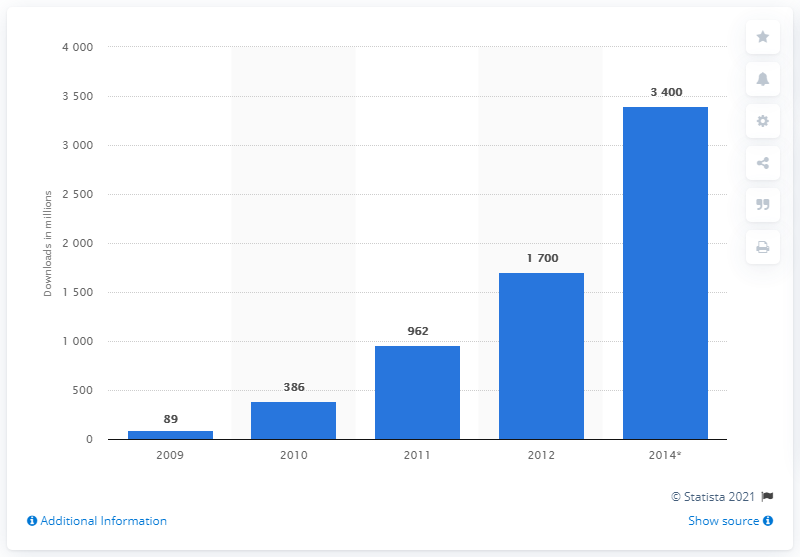Give some essential details in this illustration. In 2012, the total number of mobile app downloads was approximately 1,700. 